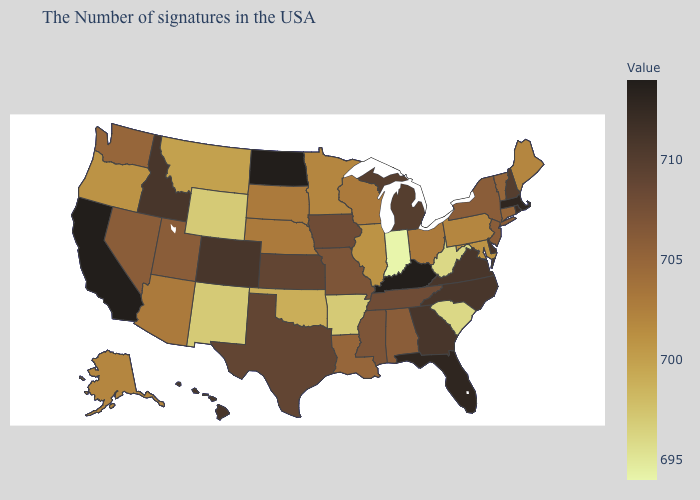Does Alaska have the highest value in the USA?
Write a very short answer. No. Does the map have missing data?
Be succinct. No. Does California have the highest value in the USA?
Write a very short answer. Yes. Does Georgia have the lowest value in the South?
Short answer required. No. Does West Virginia have the lowest value in the South?
Answer briefly. Yes. Among the states that border Oregon , which have the highest value?
Write a very short answer. California. Is the legend a continuous bar?
Give a very brief answer. Yes. Does Texas have a higher value than Utah?
Quick response, please. Yes. 